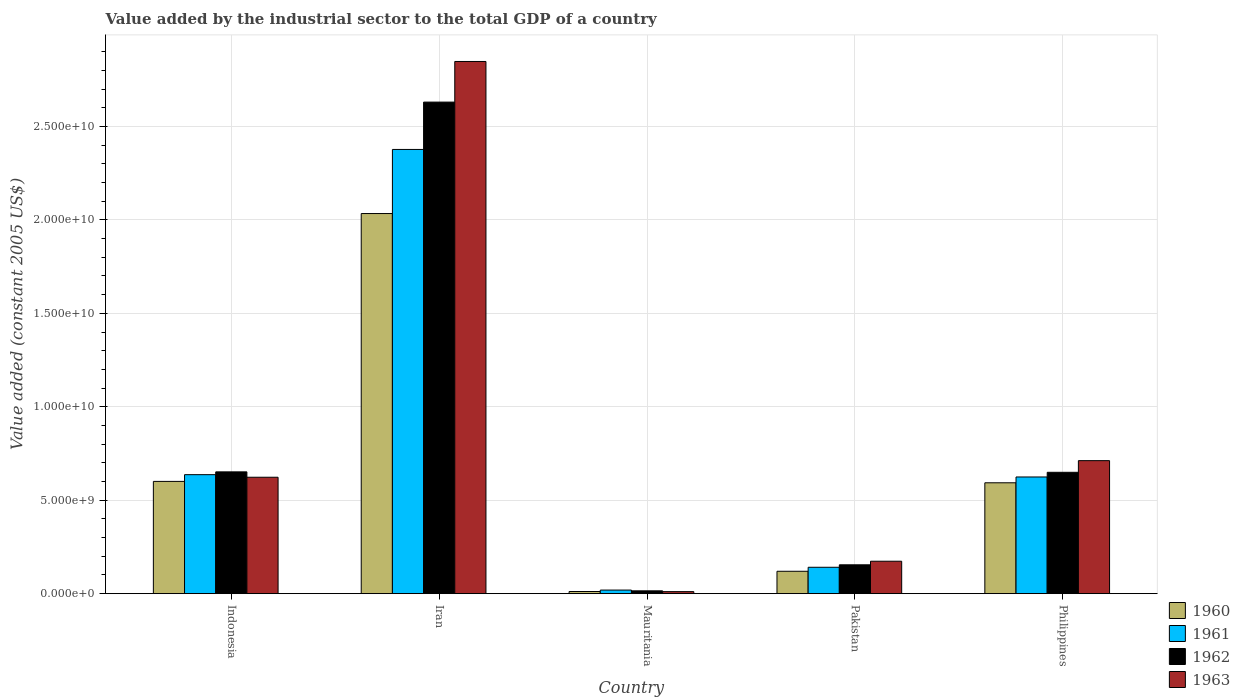How many different coloured bars are there?
Provide a succinct answer. 4. How many groups of bars are there?
Keep it short and to the point. 5. Are the number of bars per tick equal to the number of legend labels?
Your answer should be very brief. Yes. What is the label of the 3rd group of bars from the left?
Provide a short and direct response. Mauritania. What is the value added by the industrial sector in 1961 in Philippines?
Ensure brevity in your answer.  6.24e+09. Across all countries, what is the maximum value added by the industrial sector in 1960?
Provide a short and direct response. 2.03e+1. Across all countries, what is the minimum value added by the industrial sector in 1962?
Provide a short and direct response. 1.51e+08. In which country was the value added by the industrial sector in 1962 maximum?
Give a very brief answer. Iran. In which country was the value added by the industrial sector in 1962 minimum?
Make the answer very short. Mauritania. What is the total value added by the industrial sector in 1963 in the graph?
Make the answer very short. 4.37e+1. What is the difference between the value added by the industrial sector in 1960 in Mauritania and that in Pakistan?
Provide a succinct answer. -1.08e+09. What is the difference between the value added by the industrial sector in 1960 in Iran and the value added by the industrial sector in 1962 in Philippines?
Your answer should be compact. 1.38e+1. What is the average value added by the industrial sector in 1962 per country?
Offer a very short reply. 8.20e+09. What is the difference between the value added by the industrial sector of/in 1960 and value added by the industrial sector of/in 1961 in Indonesia?
Provide a succinct answer. -3.60e+08. What is the ratio of the value added by the industrial sector in 1961 in Iran to that in Philippines?
Give a very brief answer. 3.81. Is the value added by the industrial sector in 1960 in Indonesia less than that in Philippines?
Make the answer very short. No. Is the difference between the value added by the industrial sector in 1960 in Iran and Pakistan greater than the difference between the value added by the industrial sector in 1961 in Iran and Pakistan?
Give a very brief answer. No. What is the difference between the highest and the second highest value added by the industrial sector in 1961?
Provide a short and direct response. -1.74e+1. What is the difference between the highest and the lowest value added by the industrial sector in 1960?
Your response must be concise. 2.02e+1. Is the sum of the value added by the industrial sector in 1961 in Indonesia and Philippines greater than the maximum value added by the industrial sector in 1963 across all countries?
Keep it short and to the point. No. Is it the case that in every country, the sum of the value added by the industrial sector in 1960 and value added by the industrial sector in 1962 is greater than the sum of value added by the industrial sector in 1961 and value added by the industrial sector in 1963?
Offer a very short reply. No. What does the 3rd bar from the left in Pakistan represents?
Provide a short and direct response. 1962. What does the 3rd bar from the right in Pakistan represents?
Provide a succinct answer. 1961. Is it the case that in every country, the sum of the value added by the industrial sector in 1961 and value added by the industrial sector in 1962 is greater than the value added by the industrial sector in 1963?
Offer a terse response. Yes. What is the difference between two consecutive major ticks on the Y-axis?
Your answer should be very brief. 5.00e+09. Does the graph contain grids?
Provide a short and direct response. Yes. What is the title of the graph?
Provide a succinct answer. Value added by the industrial sector to the total GDP of a country. Does "1979" appear as one of the legend labels in the graph?
Your response must be concise. No. What is the label or title of the Y-axis?
Offer a terse response. Value added (constant 2005 US$). What is the Value added (constant 2005 US$) in 1960 in Indonesia?
Offer a terse response. 6.01e+09. What is the Value added (constant 2005 US$) in 1961 in Indonesia?
Your response must be concise. 6.37e+09. What is the Value added (constant 2005 US$) of 1962 in Indonesia?
Your answer should be compact. 6.52e+09. What is the Value added (constant 2005 US$) in 1963 in Indonesia?
Offer a terse response. 6.23e+09. What is the Value added (constant 2005 US$) in 1960 in Iran?
Provide a short and direct response. 2.03e+1. What is the Value added (constant 2005 US$) in 1961 in Iran?
Your response must be concise. 2.38e+1. What is the Value added (constant 2005 US$) of 1962 in Iran?
Offer a terse response. 2.63e+1. What is the Value added (constant 2005 US$) of 1963 in Iran?
Make the answer very short. 2.85e+1. What is the Value added (constant 2005 US$) of 1960 in Mauritania?
Make the answer very short. 1.15e+08. What is the Value added (constant 2005 US$) in 1961 in Mauritania?
Provide a succinct answer. 1.92e+08. What is the Value added (constant 2005 US$) of 1962 in Mauritania?
Make the answer very short. 1.51e+08. What is the Value added (constant 2005 US$) in 1963 in Mauritania?
Give a very brief answer. 1.08e+08. What is the Value added (constant 2005 US$) in 1960 in Pakistan?
Ensure brevity in your answer.  1.20e+09. What is the Value added (constant 2005 US$) in 1961 in Pakistan?
Offer a terse response. 1.41e+09. What is the Value added (constant 2005 US$) of 1962 in Pakistan?
Your response must be concise. 1.54e+09. What is the Value added (constant 2005 US$) in 1963 in Pakistan?
Offer a terse response. 1.74e+09. What is the Value added (constant 2005 US$) in 1960 in Philippines?
Ensure brevity in your answer.  5.93e+09. What is the Value added (constant 2005 US$) of 1961 in Philippines?
Keep it short and to the point. 6.24e+09. What is the Value added (constant 2005 US$) of 1962 in Philippines?
Your answer should be compact. 6.49e+09. What is the Value added (constant 2005 US$) in 1963 in Philippines?
Your response must be concise. 7.12e+09. Across all countries, what is the maximum Value added (constant 2005 US$) in 1960?
Make the answer very short. 2.03e+1. Across all countries, what is the maximum Value added (constant 2005 US$) in 1961?
Ensure brevity in your answer.  2.38e+1. Across all countries, what is the maximum Value added (constant 2005 US$) of 1962?
Your response must be concise. 2.63e+1. Across all countries, what is the maximum Value added (constant 2005 US$) of 1963?
Make the answer very short. 2.85e+1. Across all countries, what is the minimum Value added (constant 2005 US$) of 1960?
Keep it short and to the point. 1.15e+08. Across all countries, what is the minimum Value added (constant 2005 US$) in 1961?
Your answer should be very brief. 1.92e+08. Across all countries, what is the minimum Value added (constant 2005 US$) of 1962?
Your answer should be very brief. 1.51e+08. Across all countries, what is the minimum Value added (constant 2005 US$) in 1963?
Offer a terse response. 1.08e+08. What is the total Value added (constant 2005 US$) in 1960 in the graph?
Your answer should be very brief. 3.36e+1. What is the total Value added (constant 2005 US$) of 1961 in the graph?
Offer a very short reply. 3.80e+1. What is the total Value added (constant 2005 US$) in 1962 in the graph?
Offer a terse response. 4.10e+1. What is the total Value added (constant 2005 US$) of 1963 in the graph?
Offer a very short reply. 4.37e+1. What is the difference between the Value added (constant 2005 US$) in 1960 in Indonesia and that in Iran?
Provide a short and direct response. -1.43e+1. What is the difference between the Value added (constant 2005 US$) in 1961 in Indonesia and that in Iran?
Your response must be concise. -1.74e+1. What is the difference between the Value added (constant 2005 US$) in 1962 in Indonesia and that in Iran?
Make the answer very short. -1.98e+1. What is the difference between the Value added (constant 2005 US$) of 1963 in Indonesia and that in Iran?
Your answer should be very brief. -2.22e+1. What is the difference between the Value added (constant 2005 US$) of 1960 in Indonesia and that in Mauritania?
Your answer should be very brief. 5.89e+09. What is the difference between the Value added (constant 2005 US$) of 1961 in Indonesia and that in Mauritania?
Your answer should be compact. 6.17e+09. What is the difference between the Value added (constant 2005 US$) in 1962 in Indonesia and that in Mauritania?
Give a very brief answer. 6.37e+09. What is the difference between the Value added (constant 2005 US$) in 1963 in Indonesia and that in Mauritania?
Keep it short and to the point. 6.12e+09. What is the difference between the Value added (constant 2005 US$) of 1960 in Indonesia and that in Pakistan?
Your answer should be compact. 4.81e+09. What is the difference between the Value added (constant 2005 US$) of 1961 in Indonesia and that in Pakistan?
Your answer should be very brief. 4.96e+09. What is the difference between the Value added (constant 2005 US$) in 1962 in Indonesia and that in Pakistan?
Provide a succinct answer. 4.97e+09. What is the difference between the Value added (constant 2005 US$) in 1963 in Indonesia and that in Pakistan?
Offer a very short reply. 4.49e+09. What is the difference between the Value added (constant 2005 US$) of 1960 in Indonesia and that in Philippines?
Ensure brevity in your answer.  7.44e+07. What is the difference between the Value added (constant 2005 US$) in 1961 in Indonesia and that in Philippines?
Offer a terse response. 1.23e+08. What is the difference between the Value added (constant 2005 US$) of 1962 in Indonesia and that in Philippines?
Offer a terse response. 2.37e+07. What is the difference between the Value added (constant 2005 US$) of 1963 in Indonesia and that in Philippines?
Offer a very short reply. -8.88e+08. What is the difference between the Value added (constant 2005 US$) in 1960 in Iran and that in Mauritania?
Provide a short and direct response. 2.02e+1. What is the difference between the Value added (constant 2005 US$) in 1961 in Iran and that in Mauritania?
Provide a succinct answer. 2.36e+1. What is the difference between the Value added (constant 2005 US$) of 1962 in Iran and that in Mauritania?
Provide a succinct answer. 2.62e+1. What is the difference between the Value added (constant 2005 US$) of 1963 in Iran and that in Mauritania?
Give a very brief answer. 2.84e+1. What is the difference between the Value added (constant 2005 US$) of 1960 in Iran and that in Pakistan?
Ensure brevity in your answer.  1.91e+1. What is the difference between the Value added (constant 2005 US$) of 1961 in Iran and that in Pakistan?
Your response must be concise. 2.24e+1. What is the difference between the Value added (constant 2005 US$) of 1962 in Iran and that in Pakistan?
Ensure brevity in your answer.  2.48e+1. What is the difference between the Value added (constant 2005 US$) in 1963 in Iran and that in Pakistan?
Give a very brief answer. 2.67e+1. What is the difference between the Value added (constant 2005 US$) of 1960 in Iran and that in Philippines?
Keep it short and to the point. 1.44e+1. What is the difference between the Value added (constant 2005 US$) of 1961 in Iran and that in Philippines?
Provide a succinct answer. 1.75e+1. What is the difference between the Value added (constant 2005 US$) of 1962 in Iran and that in Philippines?
Your answer should be compact. 1.98e+1. What is the difference between the Value added (constant 2005 US$) of 1963 in Iran and that in Philippines?
Give a very brief answer. 2.14e+1. What is the difference between the Value added (constant 2005 US$) in 1960 in Mauritania and that in Pakistan?
Keep it short and to the point. -1.08e+09. What is the difference between the Value added (constant 2005 US$) in 1961 in Mauritania and that in Pakistan?
Your response must be concise. -1.22e+09. What is the difference between the Value added (constant 2005 US$) in 1962 in Mauritania and that in Pakistan?
Your answer should be very brief. -1.39e+09. What is the difference between the Value added (constant 2005 US$) in 1963 in Mauritania and that in Pakistan?
Offer a terse response. -1.63e+09. What is the difference between the Value added (constant 2005 US$) of 1960 in Mauritania and that in Philippines?
Keep it short and to the point. -5.82e+09. What is the difference between the Value added (constant 2005 US$) in 1961 in Mauritania and that in Philippines?
Make the answer very short. -6.05e+09. What is the difference between the Value added (constant 2005 US$) of 1962 in Mauritania and that in Philippines?
Your response must be concise. -6.34e+09. What is the difference between the Value added (constant 2005 US$) of 1963 in Mauritania and that in Philippines?
Your response must be concise. -7.01e+09. What is the difference between the Value added (constant 2005 US$) of 1960 in Pakistan and that in Philippines?
Keep it short and to the point. -4.73e+09. What is the difference between the Value added (constant 2005 US$) of 1961 in Pakistan and that in Philippines?
Your answer should be very brief. -4.83e+09. What is the difference between the Value added (constant 2005 US$) in 1962 in Pakistan and that in Philippines?
Provide a short and direct response. -4.95e+09. What is the difference between the Value added (constant 2005 US$) of 1963 in Pakistan and that in Philippines?
Make the answer very short. -5.38e+09. What is the difference between the Value added (constant 2005 US$) in 1960 in Indonesia and the Value added (constant 2005 US$) in 1961 in Iran?
Offer a very short reply. -1.78e+1. What is the difference between the Value added (constant 2005 US$) in 1960 in Indonesia and the Value added (constant 2005 US$) in 1962 in Iran?
Your answer should be compact. -2.03e+1. What is the difference between the Value added (constant 2005 US$) of 1960 in Indonesia and the Value added (constant 2005 US$) of 1963 in Iran?
Provide a short and direct response. -2.25e+1. What is the difference between the Value added (constant 2005 US$) in 1961 in Indonesia and the Value added (constant 2005 US$) in 1962 in Iran?
Give a very brief answer. -1.99e+1. What is the difference between the Value added (constant 2005 US$) of 1961 in Indonesia and the Value added (constant 2005 US$) of 1963 in Iran?
Make the answer very short. -2.21e+1. What is the difference between the Value added (constant 2005 US$) in 1962 in Indonesia and the Value added (constant 2005 US$) in 1963 in Iran?
Ensure brevity in your answer.  -2.20e+1. What is the difference between the Value added (constant 2005 US$) in 1960 in Indonesia and the Value added (constant 2005 US$) in 1961 in Mauritania?
Give a very brief answer. 5.81e+09. What is the difference between the Value added (constant 2005 US$) of 1960 in Indonesia and the Value added (constant 2005 US$) of 1962 in Mauritania?
Provide a succinct answer. 5.86e+09. What is the difference between the Value added (constant 2005 US$) of 1960 in Indonesia and the Value added (constant 2005 US$) of 1963 in Mauritania?
Make the answer very short. 5.90e+09. What is the difference between the Value added (constant 2005 US$) in 1961 in Indonesia and the Value added (constant 2005 US$) in 1962 in Mauritania?
Provide a short and direct response. 6.22e+09. What is the difference between the Value added (constant 2005 US$) of 1961 in Indonesia and the Value added (constant 2005 US$) of 1963 in Mauritania?
Give a very brief answer. 6.26e+09. What is the difference between the Value added (constant 2005 US$) in 1962 in Indonesia and the Value added (constant 2005 US$) in 1963 in Mauritania?
Your answer should be compact. 6.41e+09. What is the difference between the Value added (constant 2005 US$) of 1960 in Indonesia and the Value added (constant 2005 US$) of 1961 in Pakistan?
Make the answer very short. 4.60e+09. What is the difference between the Value added (constant 2005 US$) of 1960 in Indonesia and the Value added (constant 2005 US$) of 1962 in Pakistan?
Your response must be concise. 4.46e+09. What is the difference between the Value added (constant 2005 US$) of 1960 in Indonesia and the Value added (constant 2005 US$) of 1963 in Pakistan?
Offer a terse response. 4.27e+09. What is the difference between the Value added (constant 2005 US$) in 1961 in Indonesia and the Value added (constant 2005 US$) in 1962 in Pakistan?
Make the answer very short. 4.82e+09. What is the difference between the Value added (constant 2005 US$) in 1961 in Indonesia and the Value added (constant 2005 US$) in 1963 in Pakistan?
Offer a very short reply. 4.63e+09. What is the difference between the Value added (constant 2005 US$) in 1962 in Indonesia and the Value added (constant 2005 US$) in 1963 in Pakistan?
Provide a short and direct response. 4.78e+09. What is the difference between the Value added (constant 2005 US$) in 1960 in Indonesia and the Value added (constant 2005 US$) in 1961 in Philippines?
Offer a very short reply. -2.37e+08. What is the difference between the Value added (constant 2005 US$) of 1960 in Indonesia and the Value added (constant 2005 US$) of 1962 in Philippines?
Your response must be concise. -4.86e+08. What is the difference between the Value added (constant 2005 US$) in 1960 in Indonesia and the Value added (constant 2005 US$) in 1963 in Philippines?
Make the answer very short. -1.11e+09. What is the difference between the Value added (constant 2005 US$) of 1961 in Indonesia and the Value added (constant 2005 US$) of 1962 in Philippines?
Keep it short and to the point. -1.26e+08. What is the difference between the Value added (constant 2005 US$) in 1961 in Indonesia and the Value added (constant 2005 US$) in 1963 in Philippines?
Offer a terse response. -7.50e+08. What is the difference between the Value added (constant 2005 US$) in 1962 in Indonesia and the Value added (constant 2005 US$) in 1963 in Philippines?
Your response must be concise. -6.01e+08. What is the difference between the Value added (constant 2005 US$) in 1960 in Iran and the Value added (constant 2005 US$) in 1961 in Mauritania?
Provide a succinct answer. 2.01e+1. What is the difference between the Value added (constant 2005 US$) in 1960 in Iran and the Value added (constant 2005 US$) in 1962 in Mauritania?
Provide a short and direct response. 2.02e+1. What is the difference between the Value added (constant 2005 US$) in 1960 in Iran and the Value added (constant 2005 US$) in 1963 in Mauritania?
Provide a succinct answer. 2.02e+1. What is the difference between the Value added (constant 2005 US$) of 1961 in Iran and the Value added (constant 2005 US$) of 1962 in Mauritania?
Your response must be concise. 2.36e+1. What is the difference between the Value added (constant 2005 US$) of 1961 in Iran and the Value added (constant 2005 US$) of 1963 in Mauritania?
Your response must be concise. 2.37e+1. What is the difference between the Value added (constant 2005 US$) in 1962 in Iran and the Value added (constant 2005 US$) in 1963 in Mauritania?
Provide a short and direct response. 2.62e+1. What is the difference between the Value added (constant 2005 US$) in 1960 in Iran and the Value added (constant 2005 US$) in 1961 in Pakistan?
Give a very brief answer. 1.89e+1. What is the difference between the Value added (constant 2005 US$) in 1960 in Iran and the Value added (constant 2005 US$) in 1962 in Pakistan?
Ensure brevity in your answer.  1.88e+1. What is the difference between the Value added (constant 2005 US$) of 1960 in Iran and the Value added (constant 2005 US$) of 1963 in Pakistan?
Make the answer very short. 1.86e+1. What is the difference between the Value added (constant 2005 US$) in 1961 in Iran and the Value added (constant 2005 US$) in 1962 in Pakistan?
Your answer should be compact. 2.22e+1. What is the difference between the Value added (constant 2005 US$) of 1961 in Iran and the Value added (constant 2005 US$) of 1963 in Pakistan?
Your answer should be very brief. 2.20e+1. What is the difference between the Value added (constant 2005 US$) in 1962 in Iran and the Value added (constant 2005 US$) in 1963 in Pakistan?
Your answer should be compact. 2.46e+1. What is the difference between the Value added (constant 2005 US$) in 1960 in Iran and the Value added (constant 2005 US$) in 1961 in Philippines?
Offer a very short reply. 1.41e+1. What is the difference between the Value added (constant 2005 US$) in 1960 in Iran and the Value added (constant 2005 US$) in 1962 in Philippines?
Offer a terse response. 1.38e+1. What is the difference between the Value added (constant 2005 US$) in 1960 in Iran and the Value added (constant 2005 US$) in 1963 in Philippines?
Offer a terse response. 1.32e+1. What is the difference between the Value added (constant 2005 US$) in 1961 in Iran and the Value added (constant 2005 US$) in 1962 in Philippines?
Ensure brevity in your answer.  1.73e+1. What is the difference between the Value added (constant 2005 US$) in 1961 in Iran and the Value added (constant 2005 US$) in 1963 in Philippines?
Your answer should be compact. 1.67e+1. What is the difference between the Value added (constant 2005 US$) in 1962 in Iran and the Value added (constant 2005 US$) in 1963 in Philippines?
Your answer should be very brief. 1.92e+1. What is the difference between the Value added (constant 2005 US$) in 1960 in Mauritania and the Value added (constant 2005 US$) in 1961 in Pakistan?
Your answer should be very brief. -1.30e+09. What is the difference between the Value added (constant 2005 US$) of 1960 in Mauritania and the Value added (constant 2005 US$) of 1962 in Pakistan?
Ensure brevity in your answer.  -1.43e+09. What is the difference between the Value added (constant 2005 US$) in 1960 in Mauritania and the Value added (constant 2005 US$) in 1963 in Pakistan?
Keep it short and to the point. -1.62e+09. What is the difference between the Value added (constant 2005 US$) of 1961 in Mauritania and the Value added (constant 2005 US$) of 1962 in Pakistan?
Give a very brief answer. -1.35e+09. What is the difference between the Value added (constant 2005 US$) of 1961 in Mauritania and the Value added (constant 2005 US$) of 1963 in Pakistan?
Give a very brief answer. -1.54e+09. What is the difference between the Value added (constant 2005 US$) of 1962 in Mauritania and the Value added (constant 2005 US$) of 1963 in Pakistan?
Offer a terse response. -1.58e+09. What is the difference between the Value added (constant 2005 US$) of 1960 in Mauritania and the Value added (constant 2005 US$) of 1961 in Philippines?
Ensure brevity in your answer.  -6.13e+09. What is the difference between the Value added (constant 2005 US$) in 1960 in Mauritania and the Value added (constant 2005 US$) in 1962 in Philippines?
Make the answer very short. -6.38e+09. What is the difference between the Value added (constant 2005 US$) in 1960 in Mauritania and the Value added (constant 2005 US$) in 1963 in Philippines?
Offer a very short reply. -7.00e+09. What is the difference between the Value added (constant 2005 US$) of 1961 in Mauritania and the Value added (constant 2005 US$) of 1962 in Philippines?
Make the answer very short. -6.30e+09. What is the difference between the Value added (constant 2005 US$) of 1961 in Mauritania and the Value added (constant 2005 US$) of 1963 in Philippines?
Provide a short and direct response. -6.93e+09. What is the difference between the Value added (constant 2005 US$) of 1962 in Mauritania and the Value added (constant 2005 US$) of 1963 in Philippines?
Provide a short and direct response. -6.97e+09. What is the difference between the Value added (constant 2005 US$) of 1960 in Pakistan and the Value added (constant 2005 US$) of 1961 in Philippines?
Make the answer very short. -5.05e+09. What is the difference between the Value added (constant 2005 US$) in 1960 in Pakistan and the Value added (constant 2005 US$) in 1962 in Philippines?
Give a very brief answer. -5.30e+09. What is the difference between the Value added (constant 2005 US$) in 1960 in Pakistan and the Value added (constant 2005 US$) in 1963 in Philippines?
Your response must be concise. -5.92e+09. What is the difference between the Value added (constant 2005 US$) in 1961 in Pakistan and the Value added (constant 2005 US$) in 1962 in Philippines?
Your answer should be very brief. -5.08e+09. What is the difference between the Value added (constant 2005 US$) of 1961 in Pakistan and the Value added (constant 2005 US$) of 1963 in Philippines?
Your answer should be very brief. -5.71e+09. What is the difference between the Value added (constant 2005 US$) in 1962 in Pakistan and the Value added (constant 2005 US$) in 1963 in Philippines?
Your answer should be compact. -5.57e+09. What is the average Value added (constant 2005 US$) of 1960 per country?
Keep it short and to the point. 6.72e+09. What is the average Value added (constant 2005 US$) in 1961 per country?
Your answer should be very brief. 7.60e+09. What is the average Value added (constant 2005 US$) of 1962 per country?
Your response must be concise. 8.20e+09. What is the average Value added (constant 2005 US$) of 1963 per country?
Keep it short and to the point. 8.73e+09. What is the difference between the Value added (constant 2005 US$) in 1960 and Value added (constant 2005 US$) in 1961 in Indonesia?
Your answer should be compact. -3.60e+08. What is the difference between the Value added (constant 2005 US$) in 1960 and Value added (constant 2005 US$) in 1962 in Indonesia?
Offer a very short reply. -5.10e+08. What is the difference between the Value added (constant 2005 US$) of 1960 and Value added (constant 2005 US$) of 1963 in Indonesia?
Your answer should be compact. -2.22e+08. What is the difference between the Value added (constant 2005 US$) of 1961 and Value added (constant 2005 US$) of 1962 in Indonesia?
Your response must be concise. -1.50e+08. What is the difference between the Value added (constant 2005 US$) in 1961 and Value added (constant 2005 US$) in 1963 in Indonesia?
Offer a very short reply. 1.38e+08. What is the difference between the Value added (constant 2005 US$) in 1962 and Value added (constant 2005 US$) in 1963 in Indonesia?
Give a very brief answer. 2.88e+08. What is the difference between the Value added (constant 2005 US$) of 1960 and Value added (constant 2005 US$) of 1961 in Iran?
Your response must be concise. -3.43e+09. What is the difference between the Value added (constant 2005 US$) of 1960 and Value added (constant 2005 US$) of 1962 in Iran?
Provide a short and direct response. -5.96e+09. What is the difference between the Value added (constant 2005 US$) in 1960 and Value added (constant 2005 US$) in 1963 in Iran?
Your answer should be very brief. -8.14e+09. What is the difference between the Value added (constant 2005 US$) of 1961 and Value added (constant 2005 US$) of 1962 in Iran?
Provide a succinct answer. -2.53e+09. What is the difference between the Value added (constant 2005 US$) in 1961 and Value added (constant 2005 US$) in 1963 in Iran?
Your answer should be very brief. -4.71e+09. What is the difference between the Value added (constant 2005 US$) of 1962 and Value added (constant 2005 US$) of 1963 in Iran?
Offer a terse response. -2.17e+09. What is the difference between the Value added (constant 2005 US$) in 1960 and Value added (constant 2005 US$) in 1961 in Mauritania?
Ensure brevity in your answer.  -7.68e+07. What is the difference between the Value added (constant 2005 US$) of 1960 and Value added (constant 2005 US$) of 1962 in Mauritania?
Offer a very short reply. -3.59e+07. What is the difference between the Value added (constant 2005 US$) of 1960 and Value added (constant 2005 US$) of 1963 in Mauritania?
Your answer should be very brief. 7.13e+06. What is the difference between the Value added (constant 2005 US$) in 1961 and Value added (constant 2005 US$) in 1962 in Mauritania?
Provide a short and direct response. 4.09e+07. What is the difference between the Value added (constant 2005 US$) of 1961 and Value added (constant 2005 US$) of 1963 in Mauritania?
Make the answer very short. 8.39e+07. What is the difference between the Value added (constant 2005 US$) of 1962 and Value added (constant 2005 US$) of 1963 in Mauritania?
Make the answer very short. 4.31e+07. What is the difference between the Value added (constant 2005 US$) of 1960 and Value added (constant 2005 US$) of 1961 in Pakistan?
Make the answer very short. -2.14e+08. What is the difference between the Value added (constant 2005 US$) in 1960 and Value added (constant 2005 US$) in 1962 in Pakistan?
Your answer should be compact. -3.45e+08. What is the difference between the Value added (constant 2005 US$) of 1960 and Value added (constant 2005 US$) of 1963 in Pakistan?
Offer a very short reply. -5.37e+08. What is the difference between the Value added (constant 2005 US$) in 1961 and Value added (constant 2005 US$) in 1962 in Pakistan?
Ensure brevity in your answer.  -1.32e+08. What is the difference between the Value added (constant 2005 US$) in 1961 and Value added (constant 2005 US$) in 1963 in Pakistan?
Your answer should be very brief. -3.23e+08. What is the difference between the Value added (constant 2005 US$) of 1962 and Value added (constant 2005 US$) of 1963 in Pakistan?
Make the answer very short. -1.92e+08. What is the difference between the Value added (constant 2005 US$) in 1960 and Value added (constant 2005 US$) in 1961 in Philippines?
Give a very brief answer. -3.11e+08. What is the difference between the Value added (constant 2005 US$) in 1960 and Value added (constant 2005 US$) in 1962 in Philippines?
Provide a short and direct response. -5.61e+08. What is the difference between the Value added (constant 2005 US$) in 1960 and Value added (constant 2005 US$) in 1963 in Philippines?
Ensure brevity in your answer.  -1.18e+09. What is the difference between the Value added (constant 2005 US$) of 1961 and Value added (constant 2005 US$) of 1962 in Philippines?
Provide a succinct answer. -2.50e+08. What is the difference between the Value added (constant 2005 US$) in 1961 and Value added (constant 2005 US$) in 1963 in Philippines?
Offer a very short reply. -8.74e+08. What is the difference between the Value added (constant 2005 US$) of 1962 and Value added (constant 2005 US$) of 1963 in Philippines?
Keep it short and to the point. -6.24e+08. What is the ratio of the Value added (constant 2005 US$) of 1960 in Indonesia to that in Iran?
Your answer should be very brief. 0.3. What is the ratio of the Value added (constant 2005 US$) in 1961 in Indonesia to that in Iran?
Ensure brevity in your answer.  0.27. What is the ratio of the Value added (constant 2005 US$) of 1962 in Indonesia to that in Iran?
Your answer should be compact. 0.25. What is the ratio of the Value added (constant 2005 US$) of 1963 in Indonesia to that in Iran?
Offer a very short reply. 0.22. What is the ratio of the Value added (constant 2005 US$) of 1960 in Indonesia to that in Mauritania?
Your answer should be very brief. 52.07. What is the ratio of the Value added (constant 2005 US$) in 1961 in Indonesia to that in Mauritania?
Offer a terse response. 33.14. What is the ratio of the Value added (constant 2005 US$) in 1962 in Indonesia to that in Mauritania?
Offer a terse response. 43.07. What is the ratio of the Value added (constant 2005 US$) of 1963 in Indonesia to that in Mauritania?
Offer a terse response. 57.56. What is the ratio of the Value added (constant 2005 US$) of 1960 in Indonesia to that in Pakistan?
Your answer should be compact. 5.01. What is the ratio of the Value added (constant 2005 US$) in 1961 in Indonesia to that in Pakistan?
Your response must be concise. 4.51. What is the ratio of the Value added (constant 2005 US$) of 1962 in Indonesia to that in Pakistan?
Provide a short and direct response. 4.22. What is the ratio of the Value added (constant 2005 US$) of 1963 in Indonesia to that in Pakistan?
Ensure brevity in your answer.  3.59. What is the ratio of the Value added (constant 2005 US$) of 1960 in Indonesia to that in Philippines?
Your response must be concise. 1.01. What is the ratio of the Value added (constant 2005 US$) of 1961 in Indonesia to that in Philippines?
Offer a very short reply. 1.02. What is the ratio of the Value added (constant 2005 US$) in 1963 in Indonesia to that in Philippines?
Provide a succinct answer. 0.88. What is the ratio of the Value added (constant 2005 US$) of 1960 in Iran to that in Mauritania?
Make the answer very short. 176.32. What is the ratio of the Value added (constant 2005 US$) in 1961 in Iran to that in Mauritania?
Your answer should be compact. 123.7. What is the ratio of the Value added (constant 2005 US$) of 1962 in Iran to that in Mauritania?
Offer a terse response. 173.84. What is the ratio of the Value added (constant 2005 US$) in 1963 in Iran to that in Mauritania?
Ensure brevity in your answer.  263.11. What is the ratio of the Value added (constant 2005 US$) of 1960 in Iran to that in Pakistan?
Make the answer very short. 16.98. What is the ratio of the Value added (constant 2005 US$) of 1961 in Iran to that in Pakistan?
Offer a terse response. 16.84. What is the ratio of the Value added (constant 2005 US$) of 1962 in Iran to that in Pakistan?
Give a very brief answer. 17.04. What is the ratio of the Value added (constant 2005 US$) in 1963 in Iran to that in Pakistan?
Provide a short and direct response. 16.41. What is the ratio of the Value added (constant 2005 US$) of 1960 in Iran to that in Philippines?
Offer a terse response. 3.43. What is the ratio of the Value added (constant 2005 US$) in 1961 in Iran to that in Philippines?
Ensure brevity in your answer.  3.81. What is the ratio of the Value added (constant 2005 US$) of 1962 in Iran to that in Philippines?
Your answer should be compact. 4.05. What is the ratio of the Value added (constant 2005 US$) in 1963 in Iran to that in Philippines?
Ensure brevity in your answer.  4. What is the ratio of the Value added (constant 2005 US$) of 1960 in Mauritania to that in Pakistan?
Give a very brief answer. 0.1. What is the ratio of the Value added (constant 2005 US$) of 1961 in Mauritania to that in Pakistan?
Offer a terse response. 0.14. What is the ratio of the Value added (constant 2005 US$) of 1962 in Mauritania to that in Pakistan?
Offer a very short reply. 0.1. What is the ratio of the Value added (constant 2005 US$) of 1963 in Mauritania to that in Pakistan?
Ensure brevity in your answer.  0.06. What is the ratio of the Value added (constant 2005 US$) in 1960 in Mauritania to that in Philippines?
Offer a very short reply. 0.02. What is the ratio of the Value added (constant 2005 US$) in 1961 in Mauritania to that in Philippines?
Give a very brief answer. 0.03. What is the ratio of the Value added (constant 2005 US$) in 1962 in Mauritania to that in Philippines?
Keep it short and to the point. 0.02. What is the ratio of the Value added (constant 2005 US$) in 1963 in Mauritania to that in Philippines?
Your answer should be compact. 0.02. What is the ratio of the Value added (constant 2005 US$) in 1960 in Pakistan to that in Philippines?
Offer a very short reply. 0.2. What is the ratio of the Value added (constant 2005 US$) of 1961 in Pakistan to that in Philippines?
Your answer should be compact. 0.23. What is the ratio of the Value added (constant 2005 US$) in 1962 in Pakistan to that in Philippines?
Ensure brevity in your answer.  0.24. What is the ratio of the Value added (constant 2005 US$) in 1963 in Pakistan to that in Philippines?
Your answer should be compact. 0.24. What is the difference between the highest and the second highest Value added (constant 2005 US$) of 1960?
Make the answer very short. 1.43e+1. What is the difference between the highest and the second highest Value added (constant 2005 US$) of 1961?
Make the answer very short. 1.74e+1. What is the difference between the highest and the second highest Value added (constant 2005 US$) in 1962?
Your answer should be compact. 1.98e+1. What is the difference between the highest and the second highest Value added (constant 2005 US$) in 1963?
Keep it short and to the point. 2.14e+1. What is the difference between the highest and the lowest Value added (constant 2005 US$) of 1960?
Provide a short and direct response. 2.02e+1. What is the difference between the highest and the lowest Value added (constant 2005 US$) in 1961?
Keep it short and to the point. 2.36e+1. What is the difference between the highest and the lowest Value added (constant 2005 US$) of 1962?
Keep it short and to the point. 2.62e+1. What is the difference between the highest and the lowest Value added (constant 2005 US$) of 1963?
Offer a very short reply. 2.84e+1. 